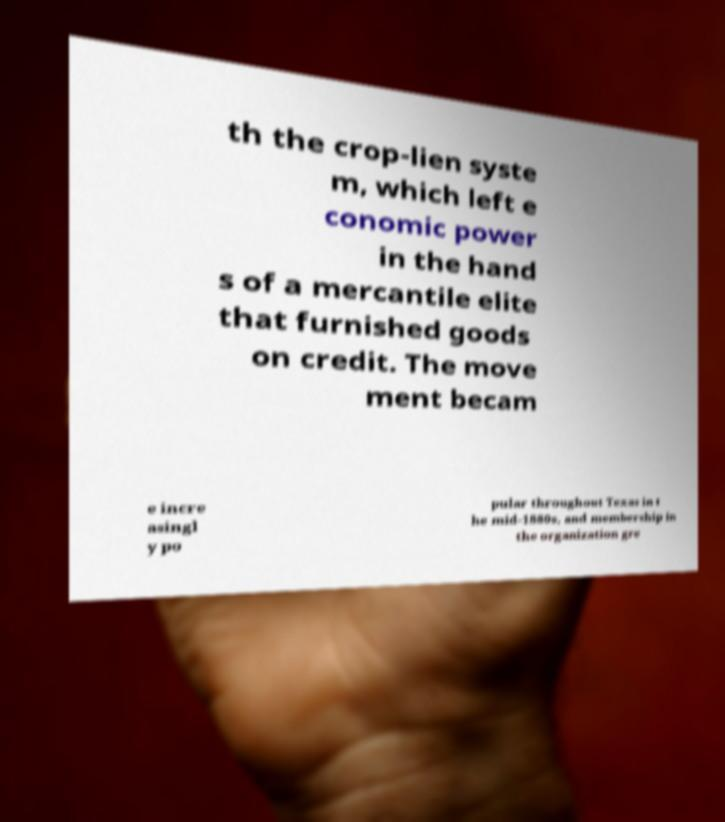For documentation purposes, I need the text within this image transcribed. Could you provide that? th the crop-lien syste m, which left e conomic power in the hand s of a mercantile elite that furnished goods on credit. The move ment becam e incre asingl y po pular throughout Texas in t he mid-1880s, and membership in the organization gre 